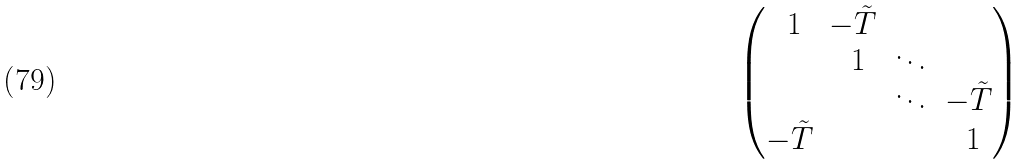Convert formula to latex. <formula><loc_0><loc_0><loc_500><loc_500>\begin{pmatrix} \ 1 & - { \tilde { T } } & & \\ & \ 1 & \ddots & \\ & & \ddots & - { \tilde { T } } \\ - { \tilde { T } } & & & \ 1 \\ \end{pmatrix}</formula> 